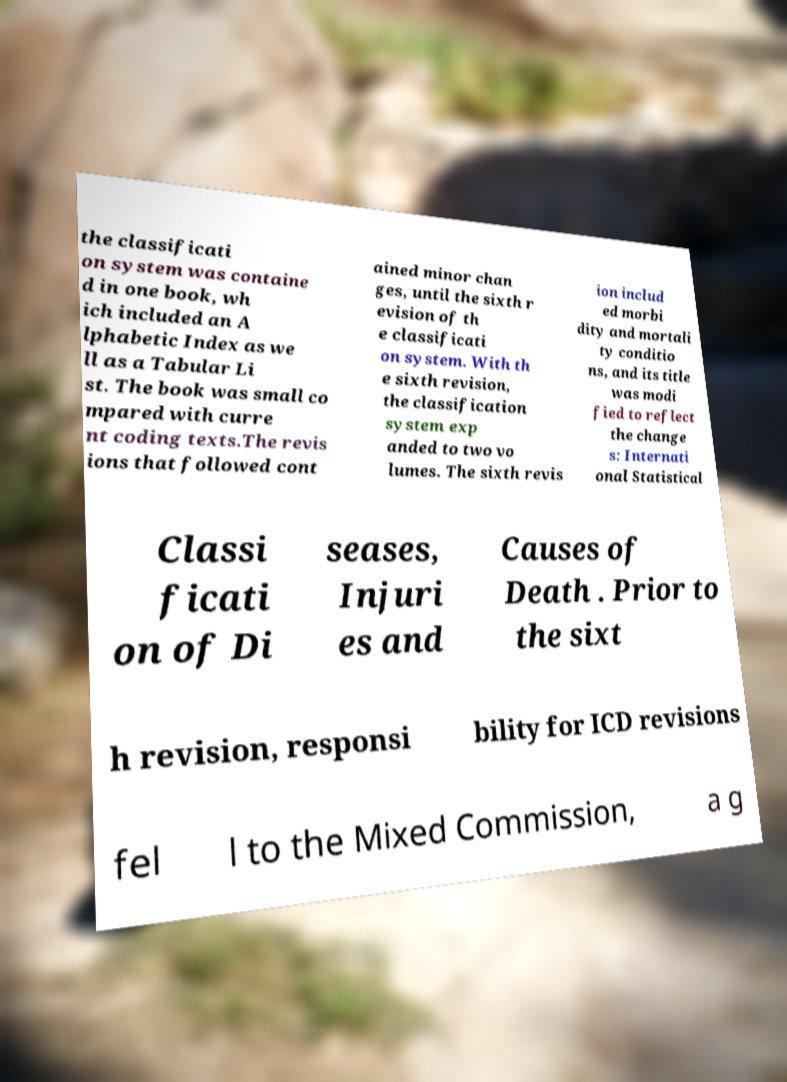Can you accurately transcribe the text from the provided image for me? the classificati on system was containe d in one book, wh ich included an A lphabetic Index as we ll as a Tabular Li st. The book was small co mpared with curre nt coding texts.The revis ions that followed cont ained minor chan ges, until the sixth r evision of th e classificati on system. With th e sixth revision, the classification system exp anded to two vo lumes. The sixth revis ion includ ed morbi dity and mortali ty conditio ns, and its title was modi fied to reflect the change s: Internati onal Statistical Classi ficati on of Di seases, Injuri es and Causes of Death . Prior to the sixt h revision, responsi bility for ICD revisions fel l to the Mixed Commission, a g 